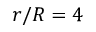<formula> <loc_0><loc_0><loc_500><loc_500>r / R = 4</formula> 